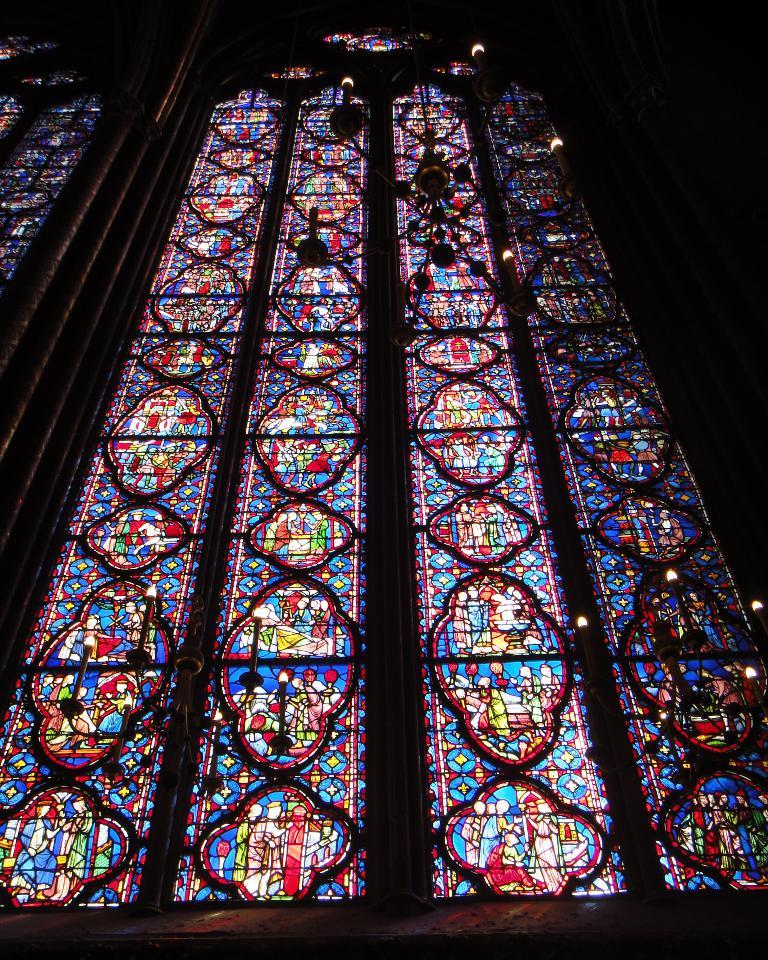What can be seen on the wall in the image? There is a wall in the image, and it has windows. What is unique about the windows on the wall? The windows are painted with pictures. What type of lighting fixture is hanging from the roof in the image? A chandelier is hanging from the roof. What type of quince is being served on the table in the image? There is no table or quince present in the image; it only features a wall with windows and a chandelier. Is the queen present in the image? There is no indication of a queen or any person in the image, as it only shows a wall with windows and a chandelier. 